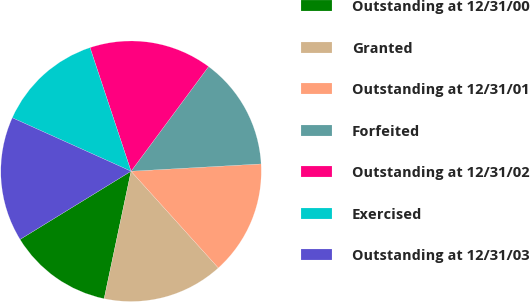<chart> <loc_0><loc_0><loc_500><loc_500><pie_chart><fcel>Outstanding at 12/31/00<fcel>Granted<fcel>Outstanding at 12/31/01<fcel>Forfeited<fcel>Outstanding at 12/31/02<fcel>Exercised<fcel>Outstanding at 12/31/03<nl><fcel>12.92%<fcel>15.0%<fcel>14.21%<fcel>13.96%<fcel>15.25%<fcel>13.17%<fcel>15.5%<nl></chart> 